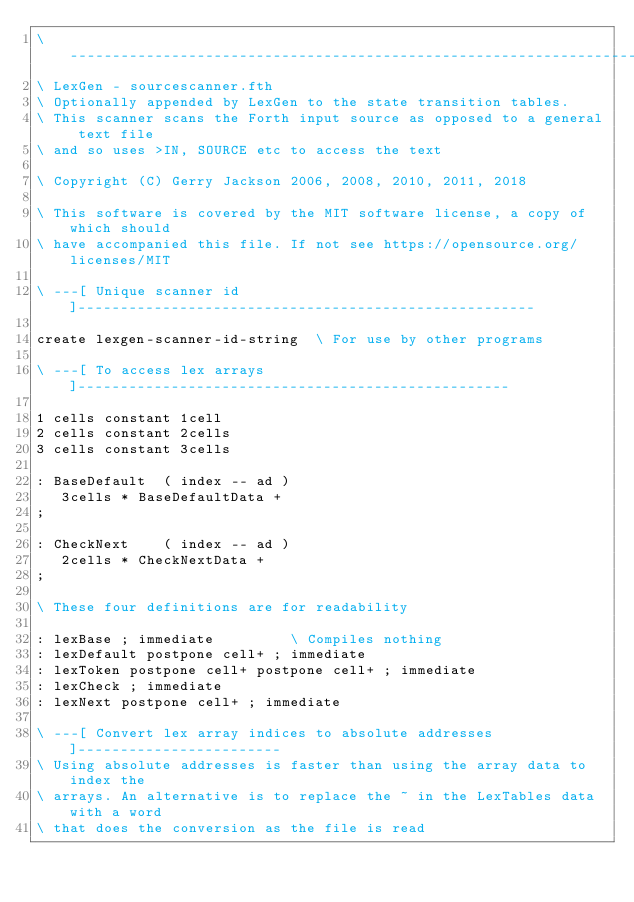<code> <loc_0><loc_0><loc_500><loc_500><_Forth_>\ ------------------------------------------------------------------------------
\ LexGen - sourcescanner.fth
\ Optionally appended by LexGen to the state transition tables.
\ This scanner scans the Forth input source as opposed to a general text file
\ and so uses >IN, SOURCE etc to access the text
 
\ Copyright (C) Gerry Jackson 2006, 2008, 2010, 2011, 2018

\ This software is covered by the MIT software license, a copy of which should
\ have accompanied this file. If not see https://opensource.org/licenses/MIT

\ ---[ Unique scanner id ]------------------------------------------------------

create lexgen-scanner-id-string  \ For use by other programs

\ ---[ To access lex arrays ]---------------------------------------------------

1 cells constant 1cell
2 cells constant 2cells
3 cells constant 3cells

: BaseDefault  ( index -- ad )
   3cells * BaseDefaultData +
;

: CheckNext    ( index -- ad )
   2cells * CheckNextData +
;

\ These four definitions are for readability

: lexBase ; immediate         \ Compiles nothing
: lexDefault postpone cell+ ; immediate
: lexToken postpone cell+ postpone cell+ ; immediate 
: lexCheck ; immediate
: lexNext postpone cell+ ; immediate

\ ---[ Convert lex array indices to absolute addresses ]------------------------
\ Using absolute addresses is faster than using the array data to index the
\ arrays. An alternative is to replace the ~ in the LexTables data with a word
\ that does the conversion as the file is read
</code> 